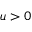<formula> <loc_0><loc_0><loc_500><loc_500>u > 0</formula> 